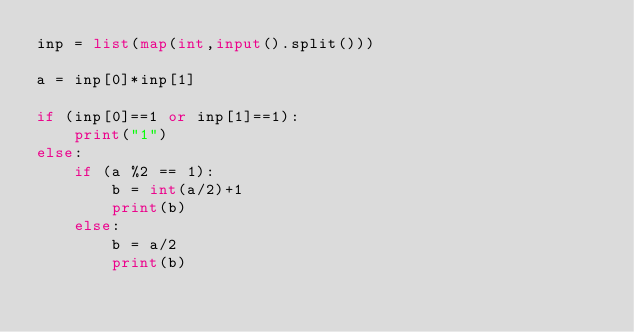Convert code to text. <code><loc_0><loc_0><loc_500><loc_500><_Python_>inp = list(map(int,input().split()))
 
a = inp[0]*inp[1]

if (inp[0]==1 or inp[1]==1):
    print("1")
else:
    if (a %2 == 1):
        b = int(a/2)+1
        print(b)
    else:
        b = a/2
        print(b)
 
</code> 